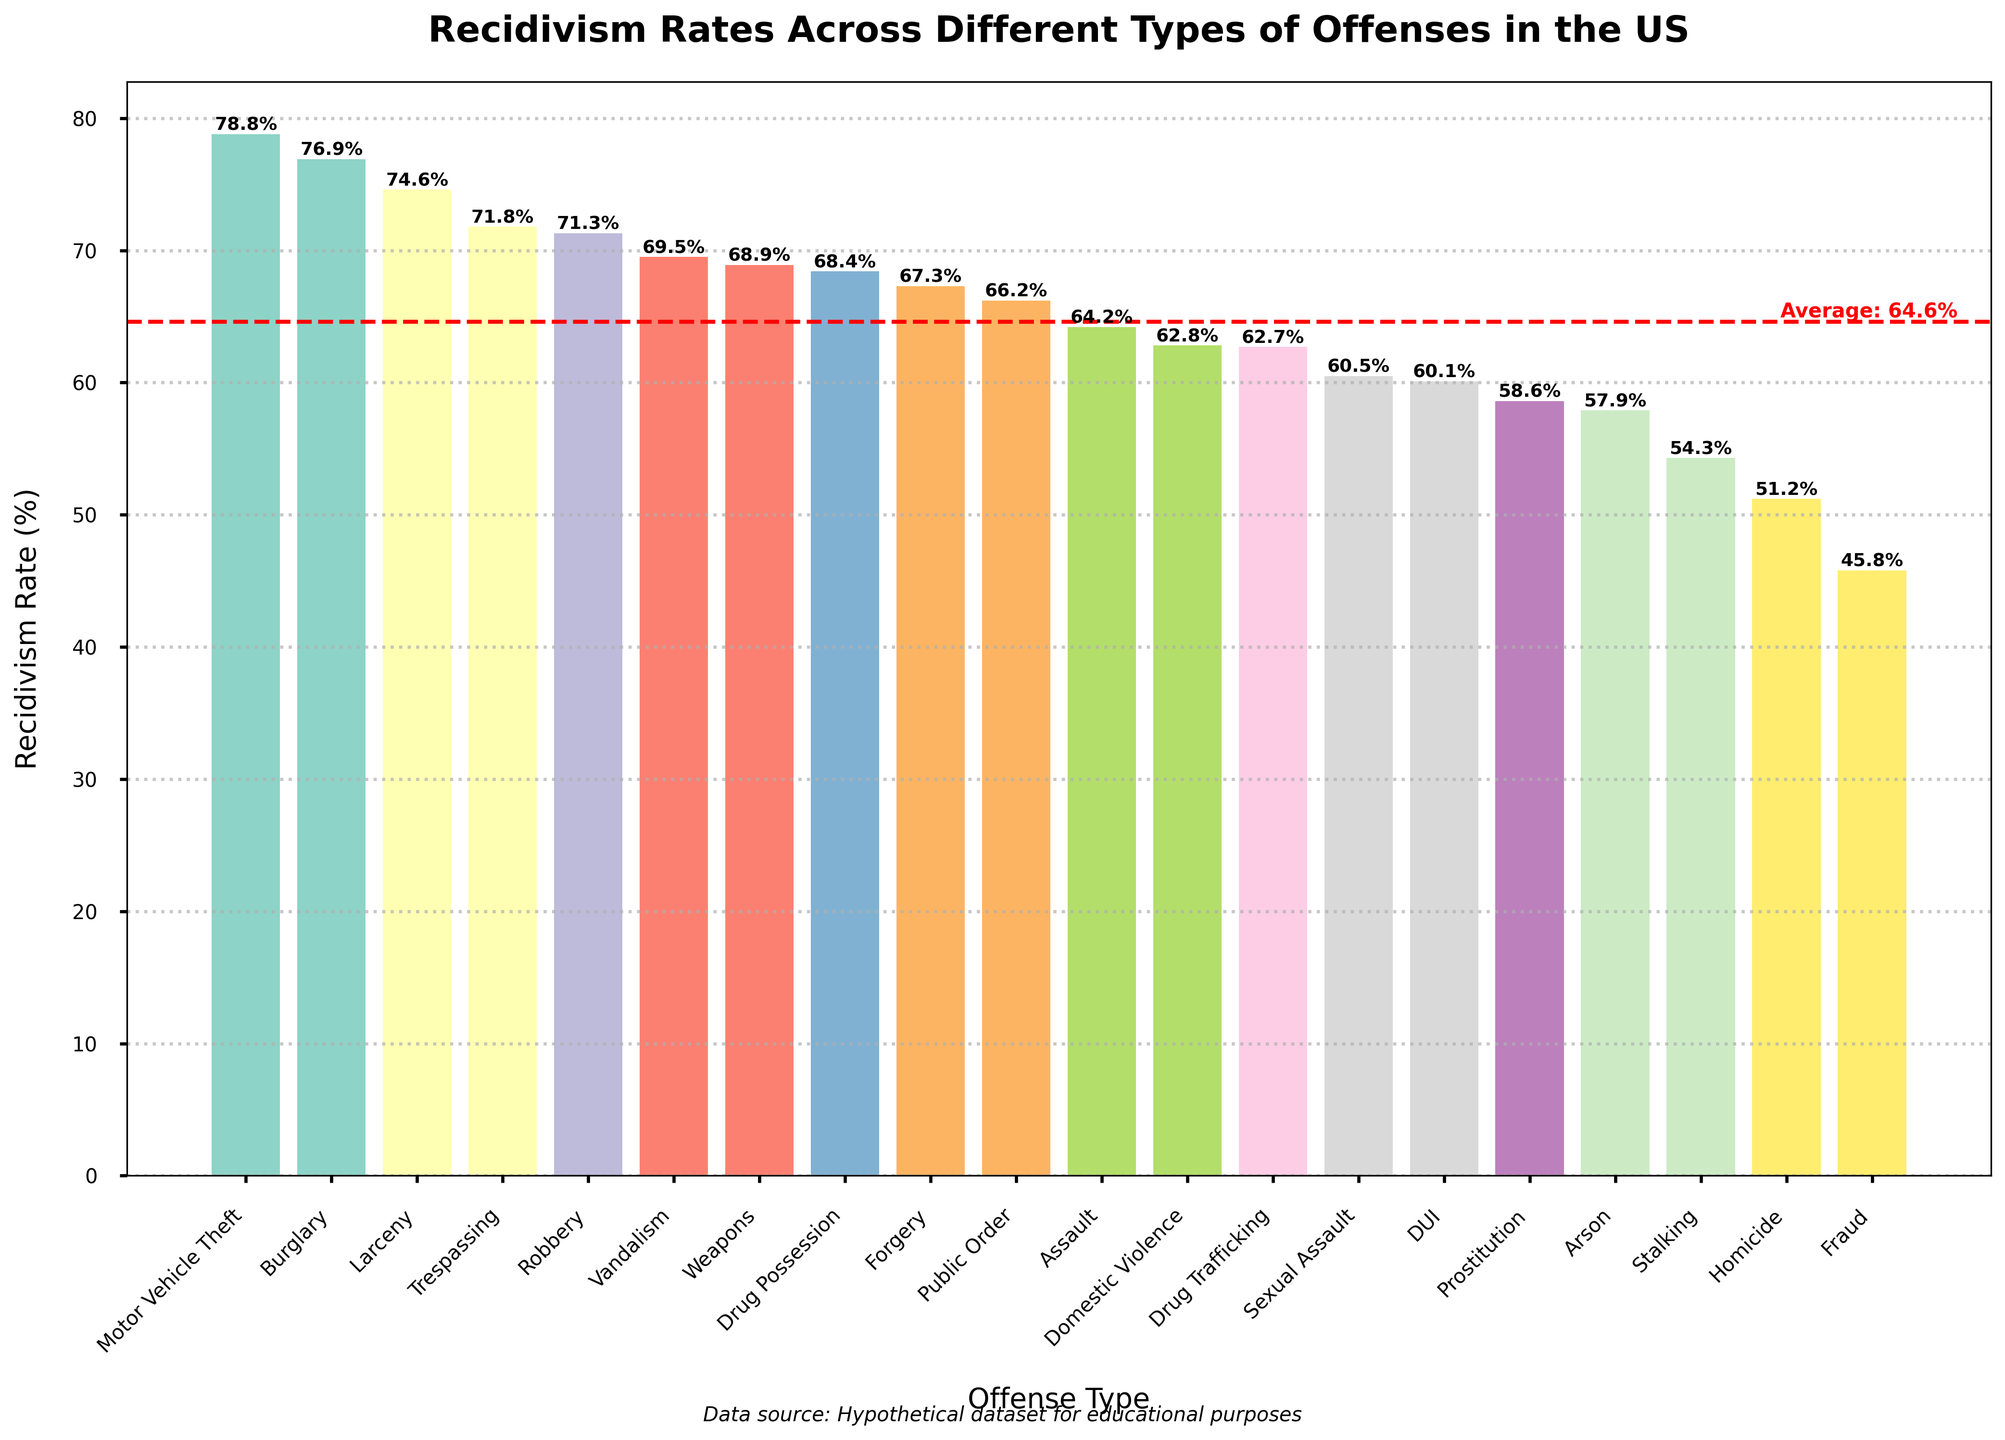Which offense type has the highest recidivism rate? By observing the heights of the bars in the chart, we see that the tallest bar represents Motor Vehicle Theft with a recidivism rate of 78.8%.
Answer: Motor Vehicle Theft Which offense type has the lowest recidivism rate? By observing the heights of the bars in the chart, we see that the shortest bar represents Fraud with a recidivism rate of 45.8%.
Answer: Fraud How does the recidivism rate for Burglary compare with Public Order? By comparing the heights of the bars representing Burglary and Public Order, we see that Burglary (76.9%) has a higher recidivism rate than Public Order (66.2%).
Answer: Burglary has a higher recidivism rate than Public Order What is the difference in recidivism rates between Arson and DUI? By noting the heights of the bars for Arson (57.9%) and DUI (60.1%), we calculate the difference: 60.1% - 57.9% = 2.2%.
Answer: 2.2% How many offense types have recidivism rates above the average rate? First, identify the average recidivism rate, which is marked by a red dotted line in the chart. Count the number of bars above this line. There are 10 offense types above the average rate.
Answer: 10 Which offense has the closest recidivism rate to the average rate? By comparing the heights of the bars to the position of the red dotted line representing the average rate, Drug Possession (68.4%) is the closest to the average rate.
Answer: Drug Possession Is the recidivism rate for Vandalism higher or lower than 70%? By observing the height of the Vandalism bar, which is at 69.5%, we see it is slightly lower than 70%.
Answer: Lower What is the combined recidivism rate for Drug Trafficking and Domestic Violence? By summing the recidivism rates for Drug Trafficking (62.7%) and Domestic Violence (62.8%), we find 62.7% + 62.8% = 125.5%.
Answer: 125.5% Which has a lower recidivism rate: Sexual Assault or Homicide? By placing the heights of the bars for Sexual Assault (60.5%) and Homicide (51.2%) side by side, Homicide has a lower recidivism rate.
Answer: Homicide What's the median recidivism rate of the offenses shown? First, list all recidivism rates in ascending order and find the middle value. For 20 values, the median is the average of the 10th (68.4%) and the 11th (68.9%) values. Hence, (68.4 + 68.9) / 2 = 68.65%.
Answer: 68.65% 